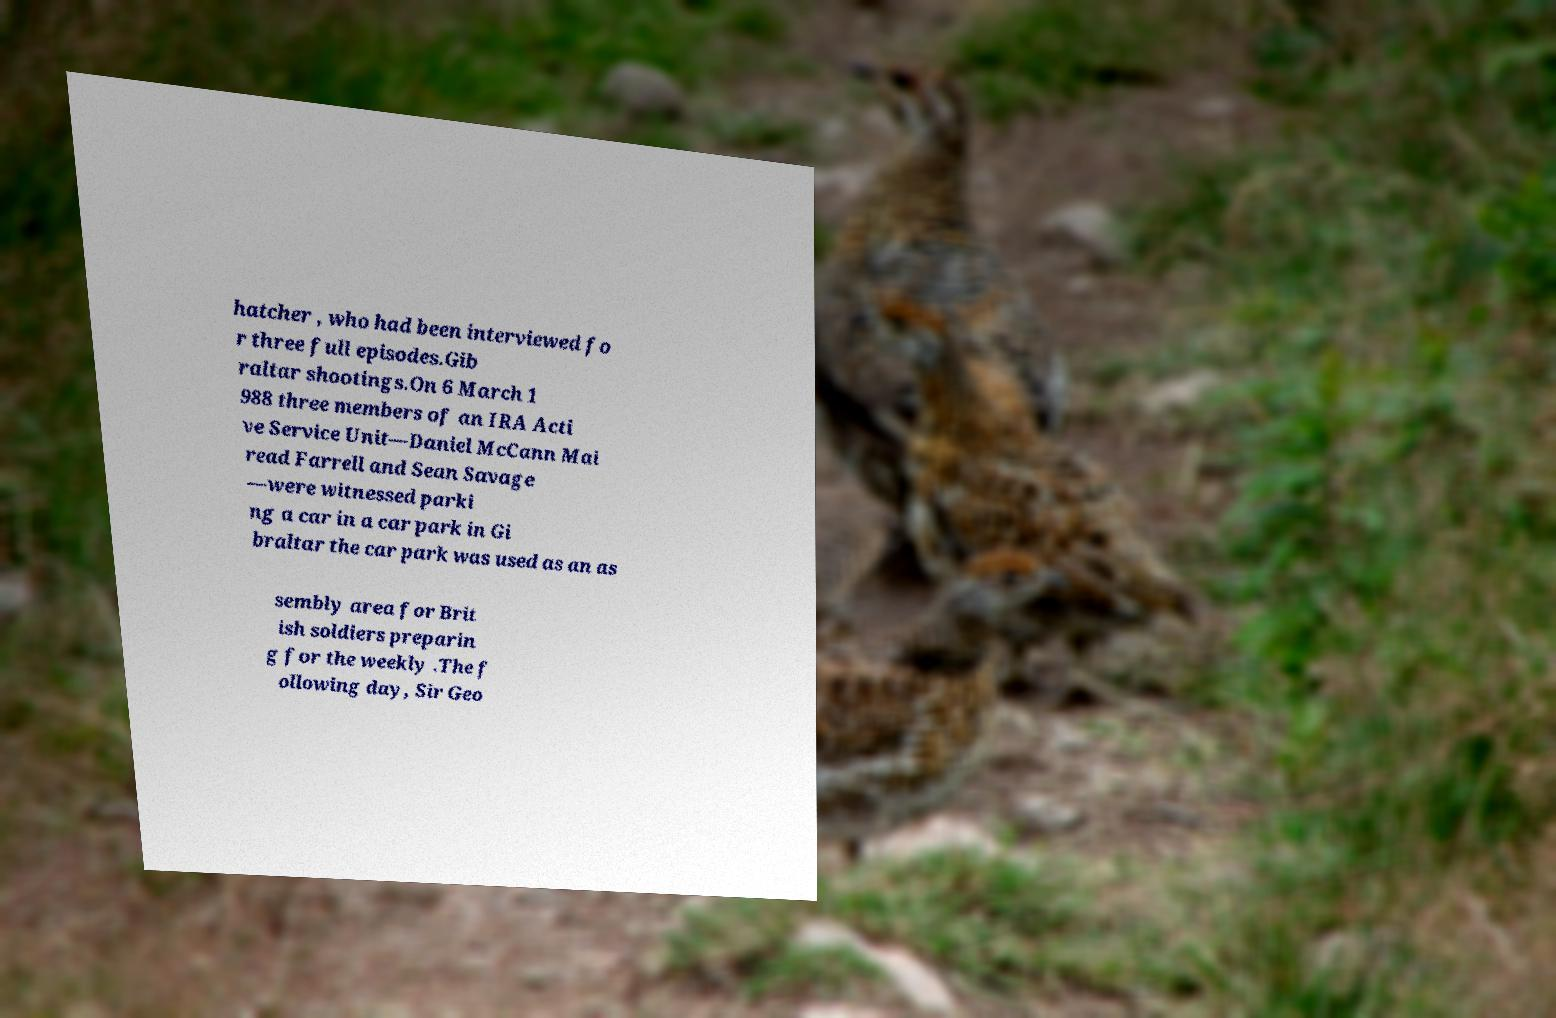For documentation purposes, I need the text within this image transcribed. Could you provide that? hatcher , who had been interviewed fo r three full episodes.Gib raltar shootings.On 6 March 1 988 three members of an IRA Acti ve Service Unit—Daniel McCann Mai read Farrell and Sean Savage —were witnessed parki ng a car in a car park in Gi braltar the car park was used as an as sembly area for Brit ish soldiers preparin g for the weekly .The f ollowing day, Sir Geo 